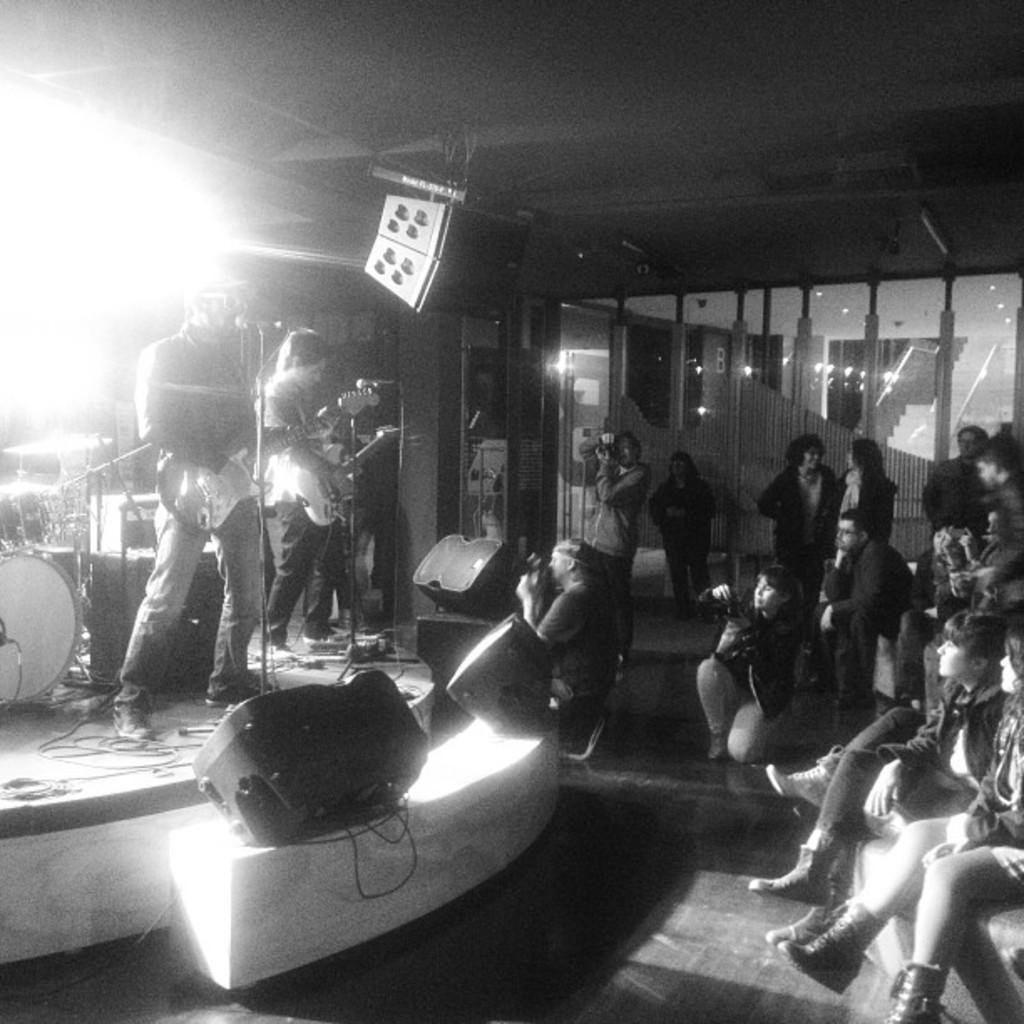How would you summarize this image in a sentence or two? There are people those who are standing on the left side of the image on the stage, by holding guitars in their hands and there is a drum set behind them, there are mics and speakers in front of them, there are people some are sitting and standing on the right side, there are stairs, lamps and glass doors in the background area, it seems to be a screen at the top side. 